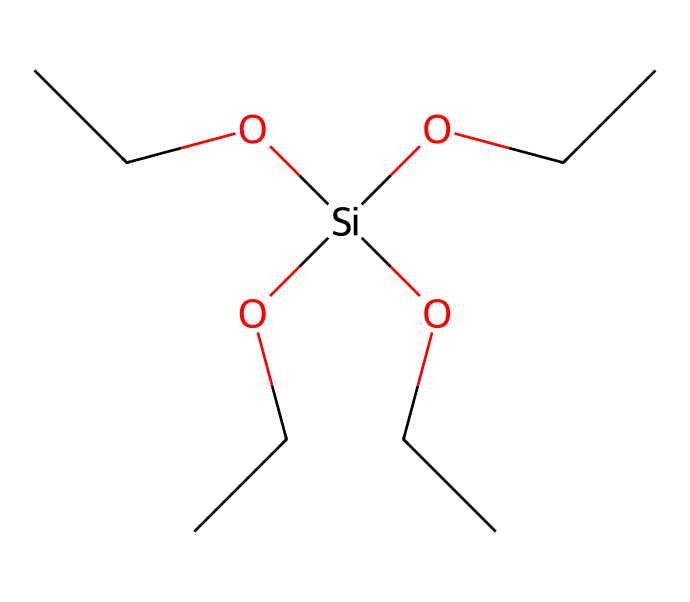How many ethoxy groups are present? The chemical structure contains four ethoxy groups, indicated by the "OCC" segments connected to the silicon atom. Each ethoxy group consists of 2 carbon atoms and 1 oxygen atom, and the "OCC" structure appears four times in total.
Answer: four What is the central atom in this structure? The central atom is silicon, represented by the "[Si]" in the SMILES notation. This indicates that silicon is the core element to which the ethoxy groups are bonded.
Answer: silicon How many total carbon atoms are in the molecule? By counting the carbon atoms in the four ethoxy groups, each containing 2 carbon atoms, we calculate 2 * 4 = 8 carbon atoms in total.
Answer: eight What type of silane is represented by this structure? The presence of multiple ethoxy groups indicates that this silane is a tetraalkoxysilane, specifically tetraethoxysilane, since there are four ethoxy moieties.
Answer: tetraalkoxysilane What is the hybridization state of the silicon atom? The silicon atom is bonded to four sigma bonds (one to each ethoxy group) and does not have lone pairs, which typically indicates sp3 hybridization.
Answer: sp3 How many oxygen atoms are in this molecule? Each ethoxy group contains one oxygen atom, and since there are four ethoxy groups, the total number of oxygen atoms is 4.
Answer: four 